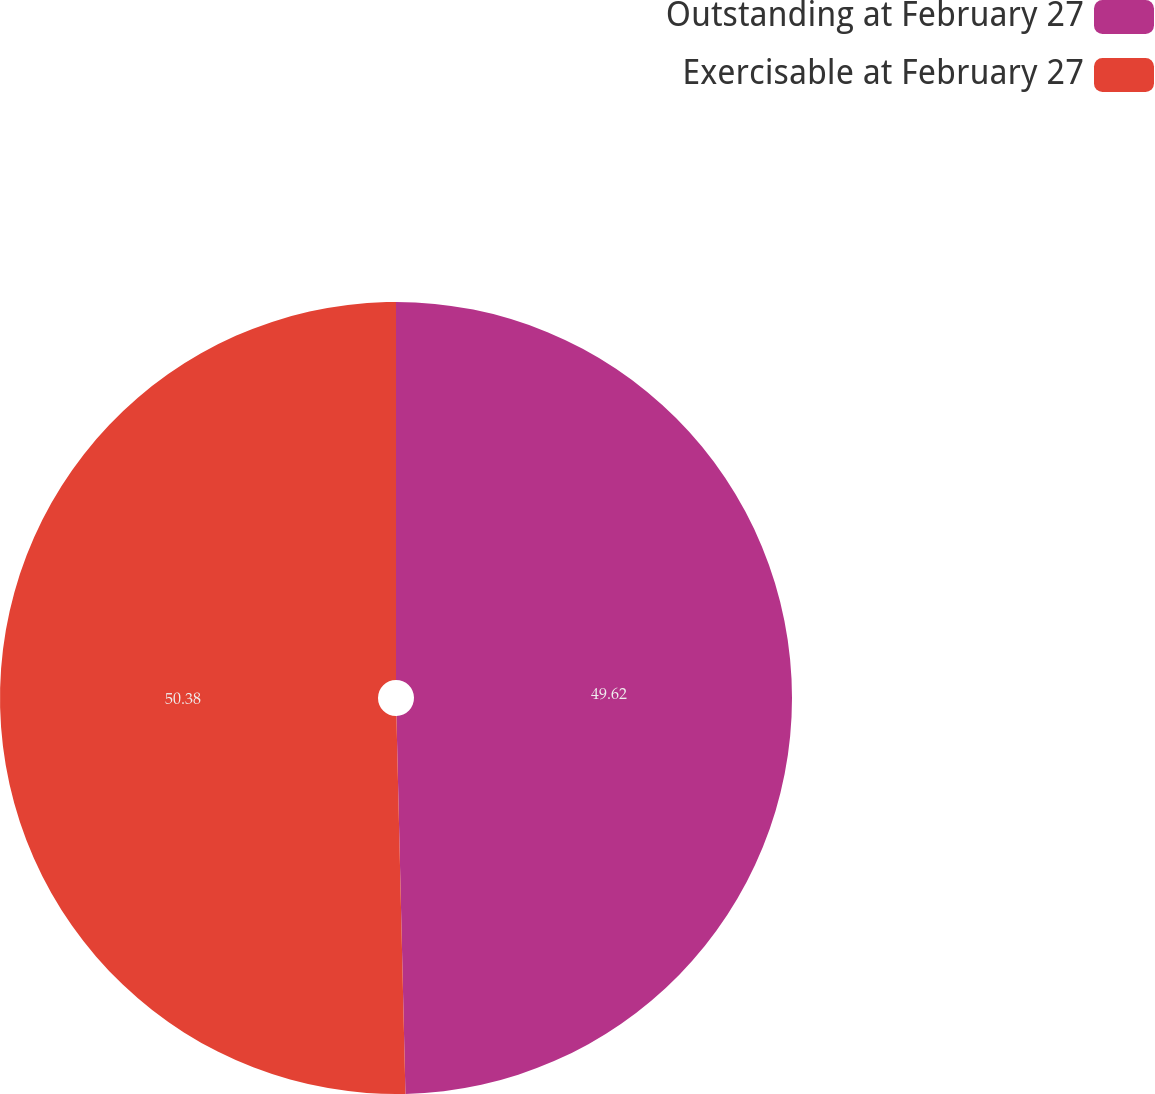Convert chart to OTSL. <chart><loc_0><loc_0><loc_500><loc_500><pie_chart><fcel>Outstanding at February 27<fcel>Exercisable at February 27<nl><fcel>49.62%<fcel>50.38%<nl></chart> 